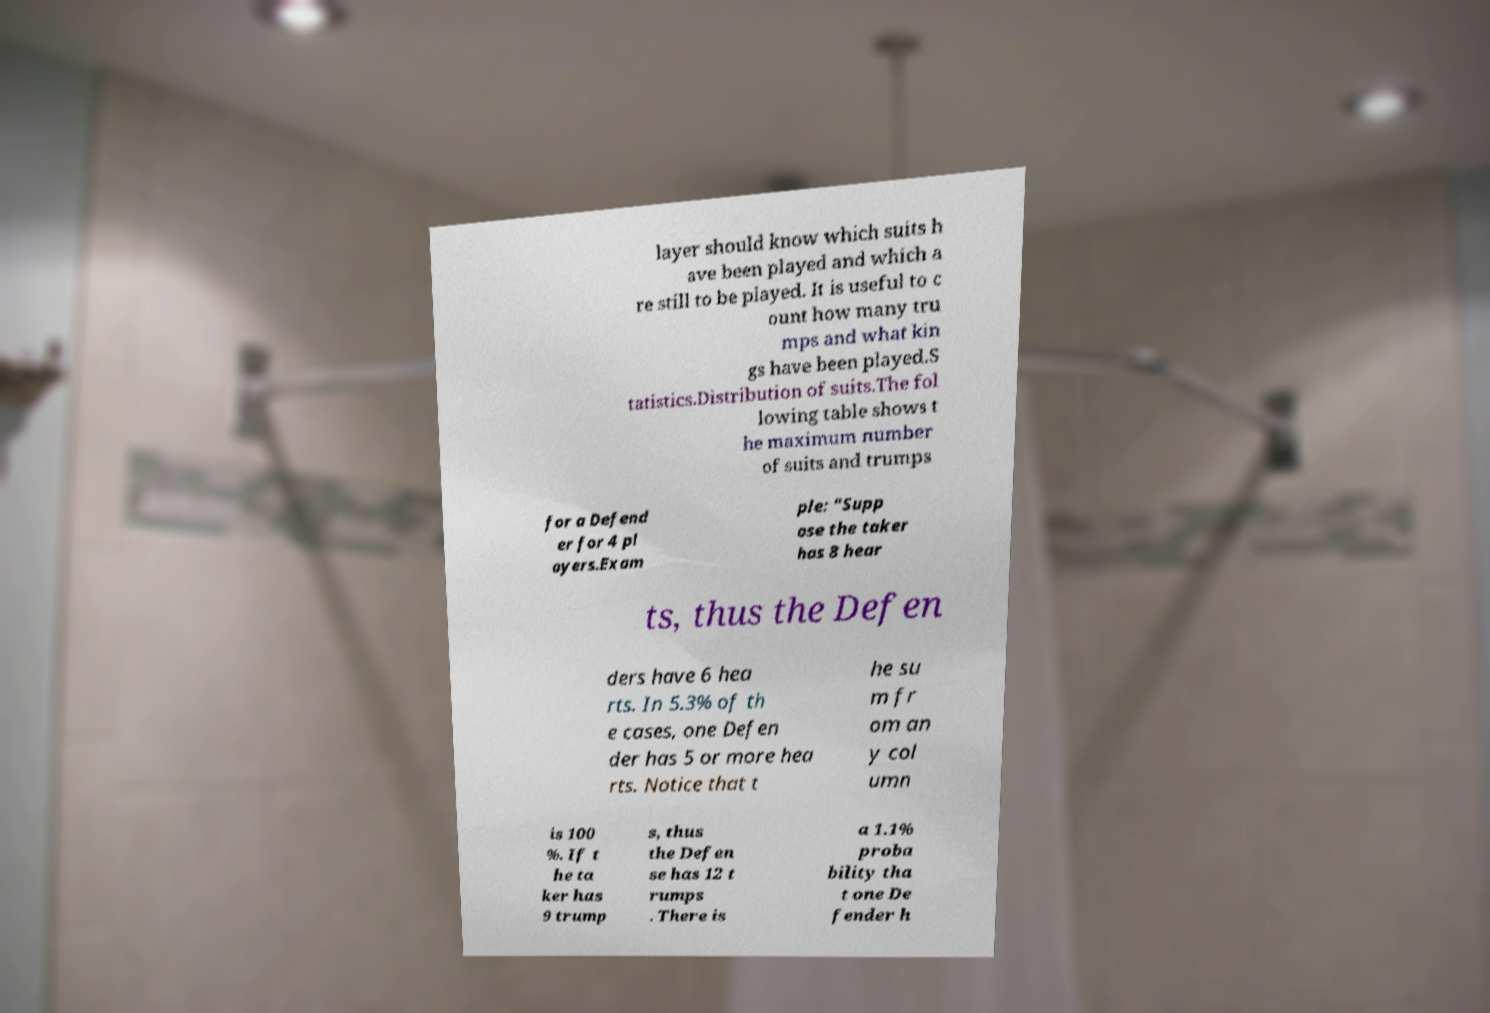Could you extract and type out the text from this image? layer should know which suits h ave been played and which a re still to be played. It is useful to c ount how many tru mps and what kin gs have been played.S tatistics.Distribution of suits.The fol lowing table shows t he maximum number of suits and trumps for a Defend er for 4 pl ayers.Exam ple: "Supp ose the taker has 8 hear ts, thus the Defen ders have 6 hea rts. In 5.3% of th e cases, one Defen der has 5 or more hea rts. Notice that t he su m fr om an y col umn is 100 %. If t he ta ker has 9 trump s, thus the Defen se has 12 t rumps . There is a 1.1% proba bility tha t one De fender h 